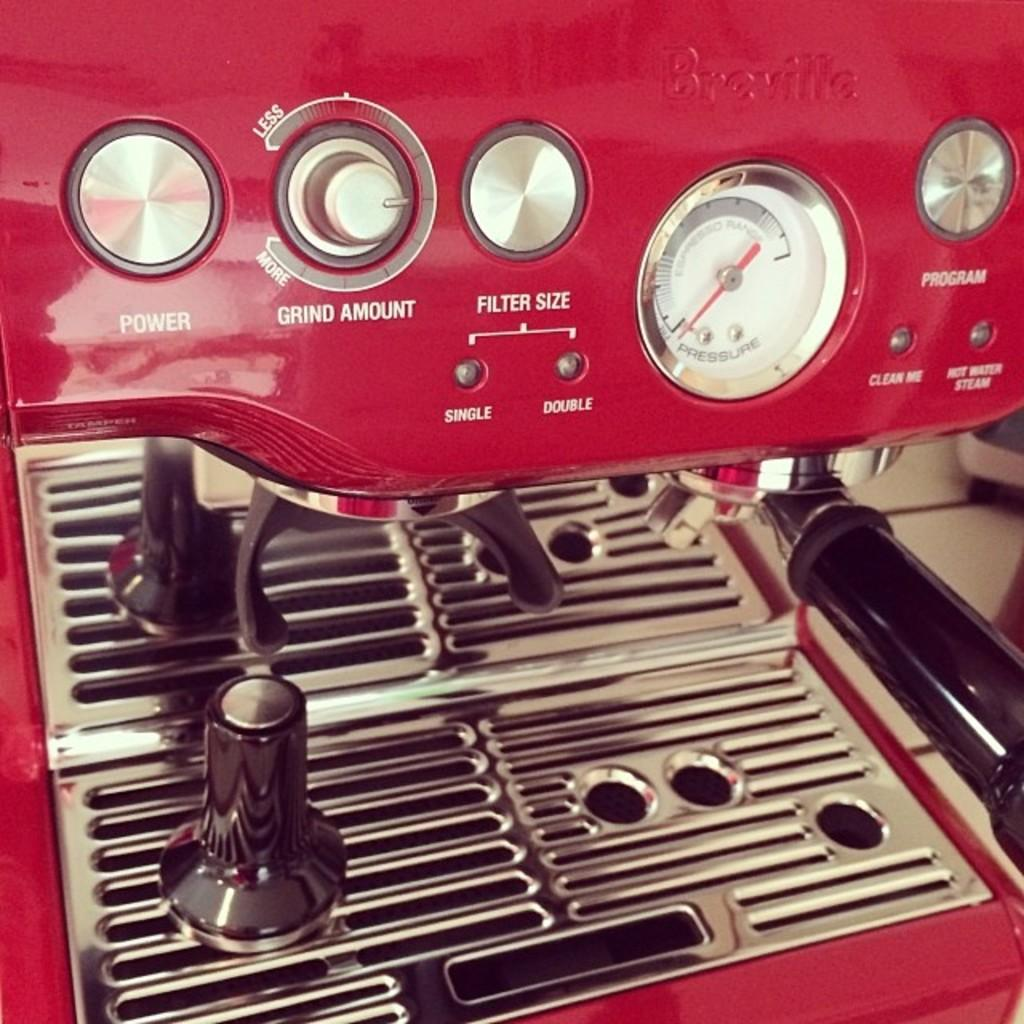What is the color of the machine in the image? The machine in the image is red. What features does the machine have? The machine has buttons, a meter, lights, and other objects. Can you describe the buttons on the machine? The facts do not provide specific details about the buttons, so we cannot describe them. Where is the scarecrow standing in the image? There is no scarecrow present in the image. What type of town is depicted in the image? The image does not show a town; it only features a red machine with various features. 